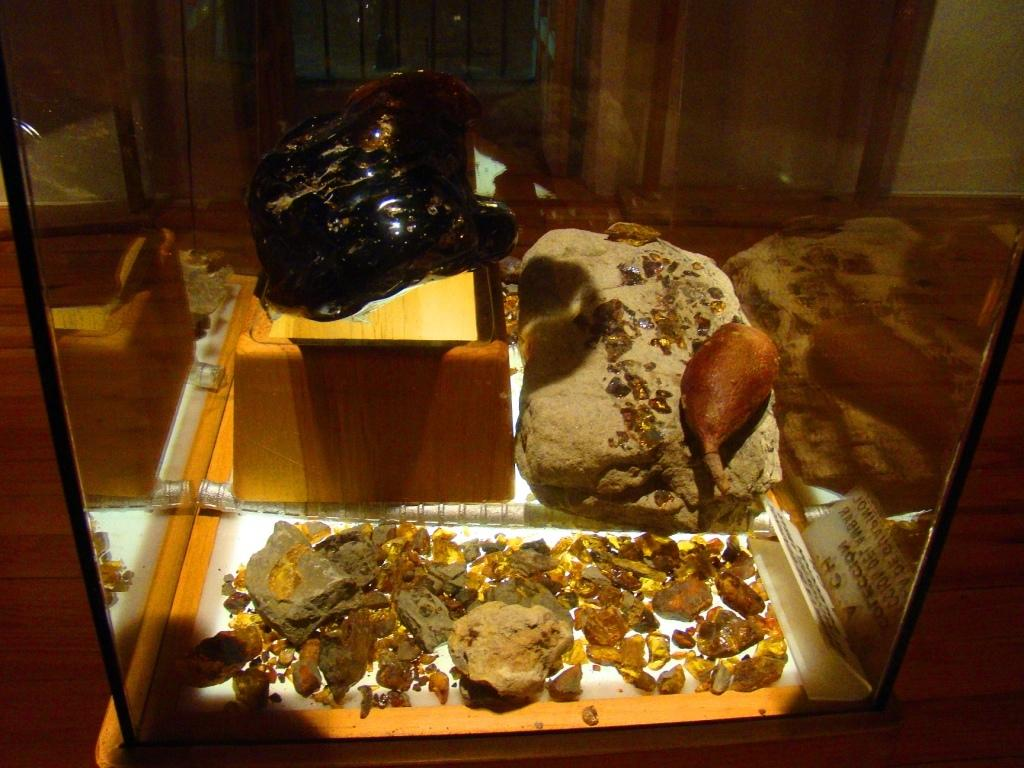What type of objects are in the image? There are stones in the image. On what surface are the stones placed? The stones are on a glass table. What type of writing can be seen on the stones in the image? There is no writing visible on the stones in the image. What unit of measurement is used to determine the size of the stones in the image? The provided facts do not mention any specific unit of measurement for the stones. What message of peace is conveyed by the stones in the image? There is no message of peace conveyed by the stones in the image, as they are simply stones placed on a glass table. 